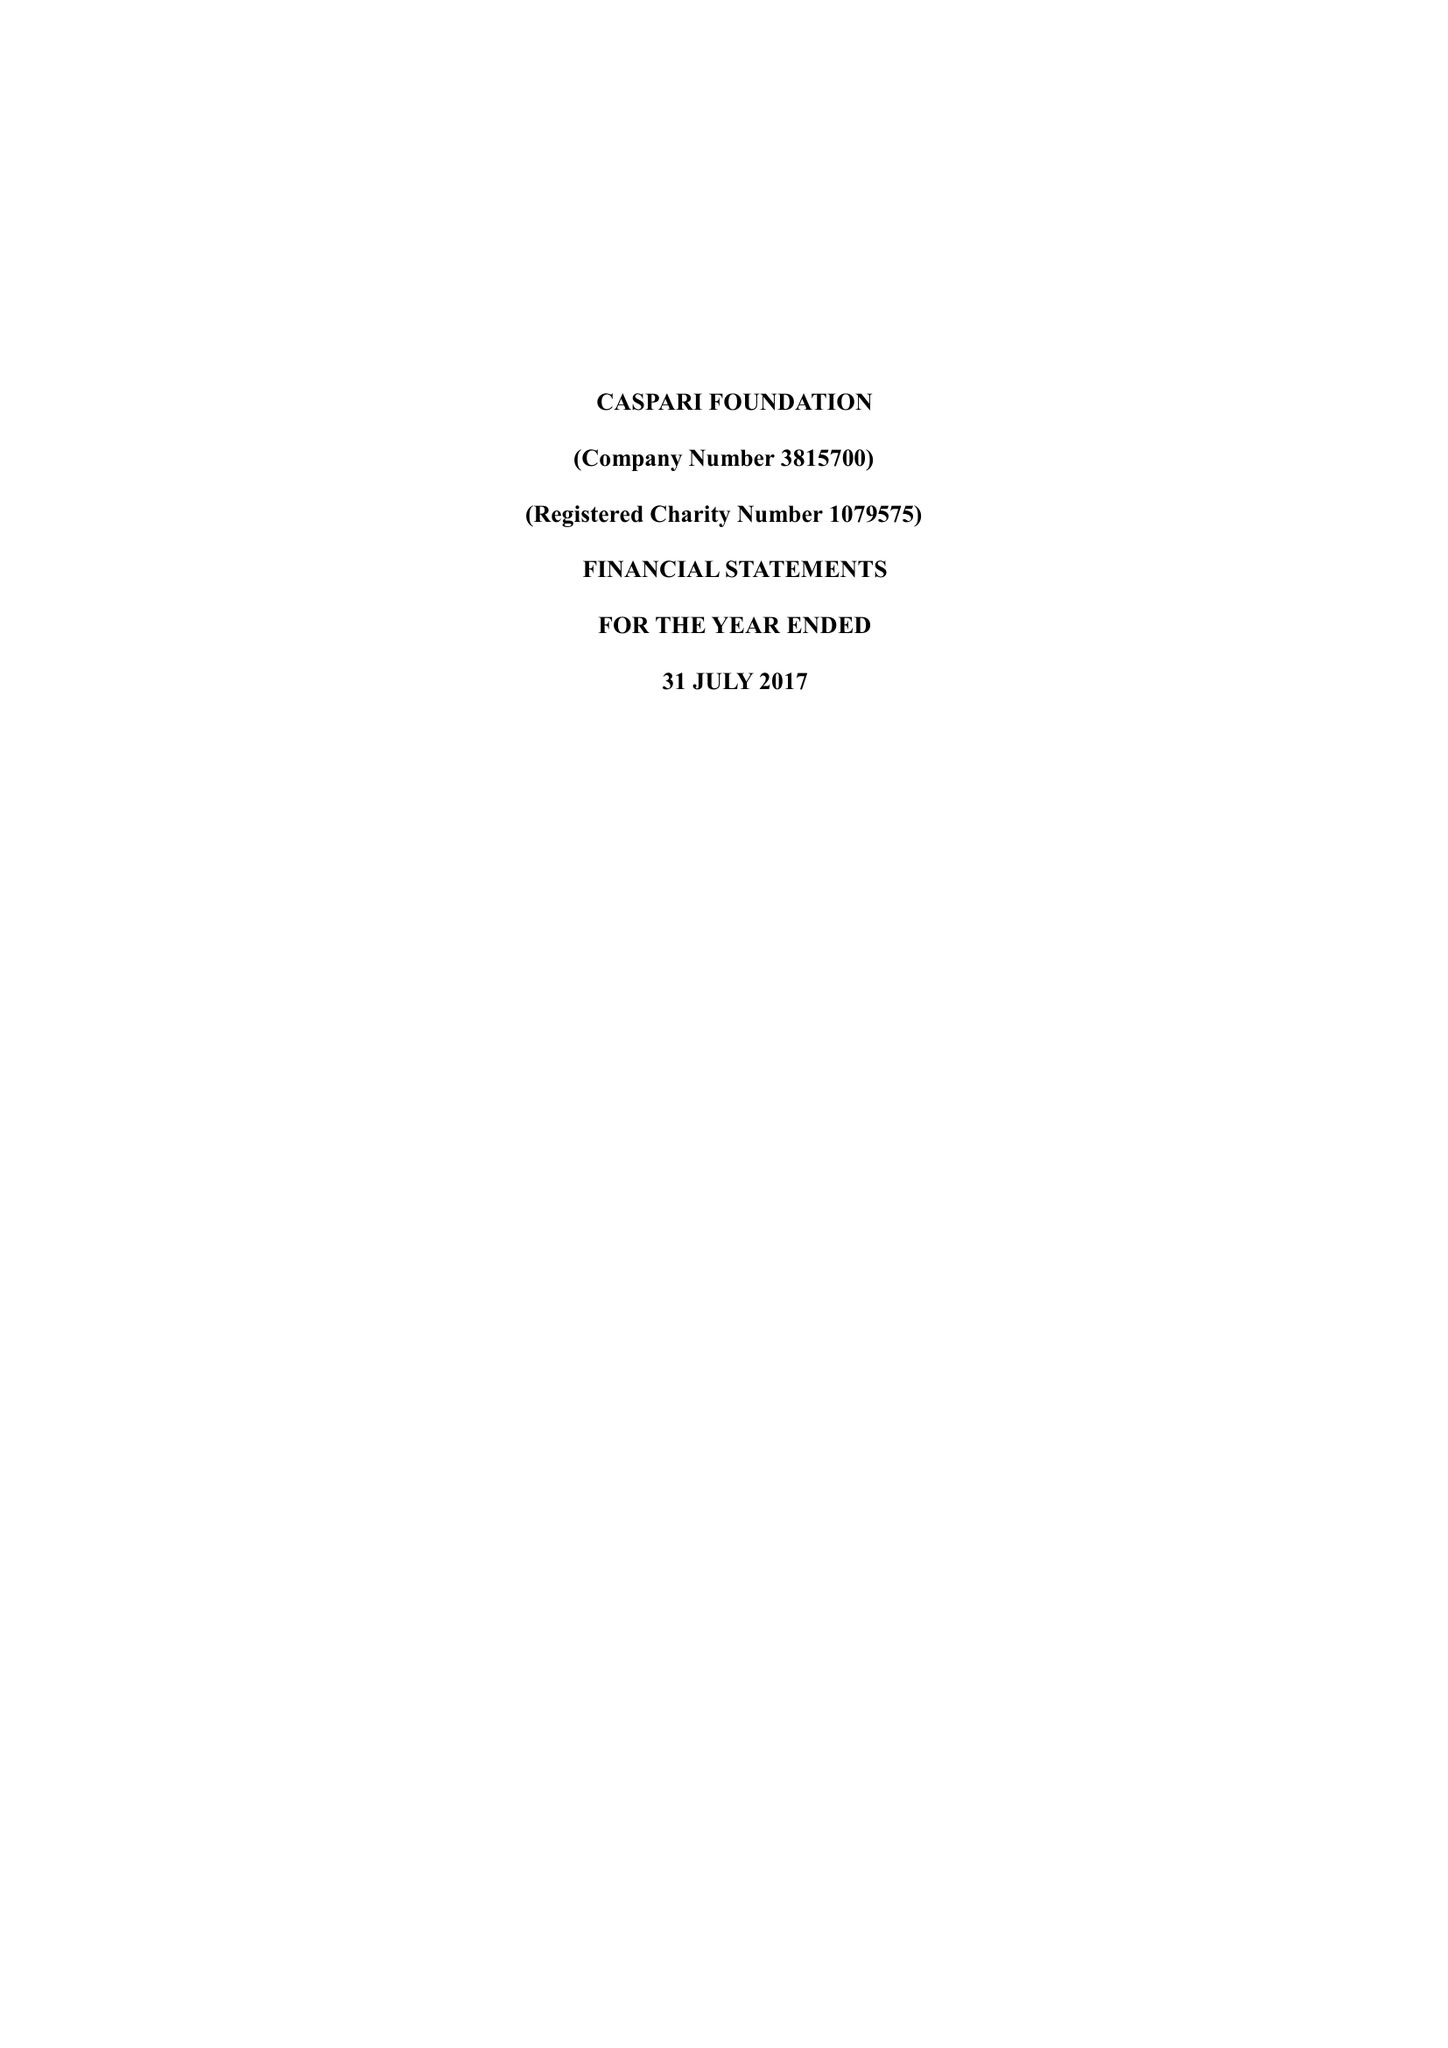What is the value for the spending_annually_in_british_pounds?
Answer the question using a single word or phrase. 174192.00 